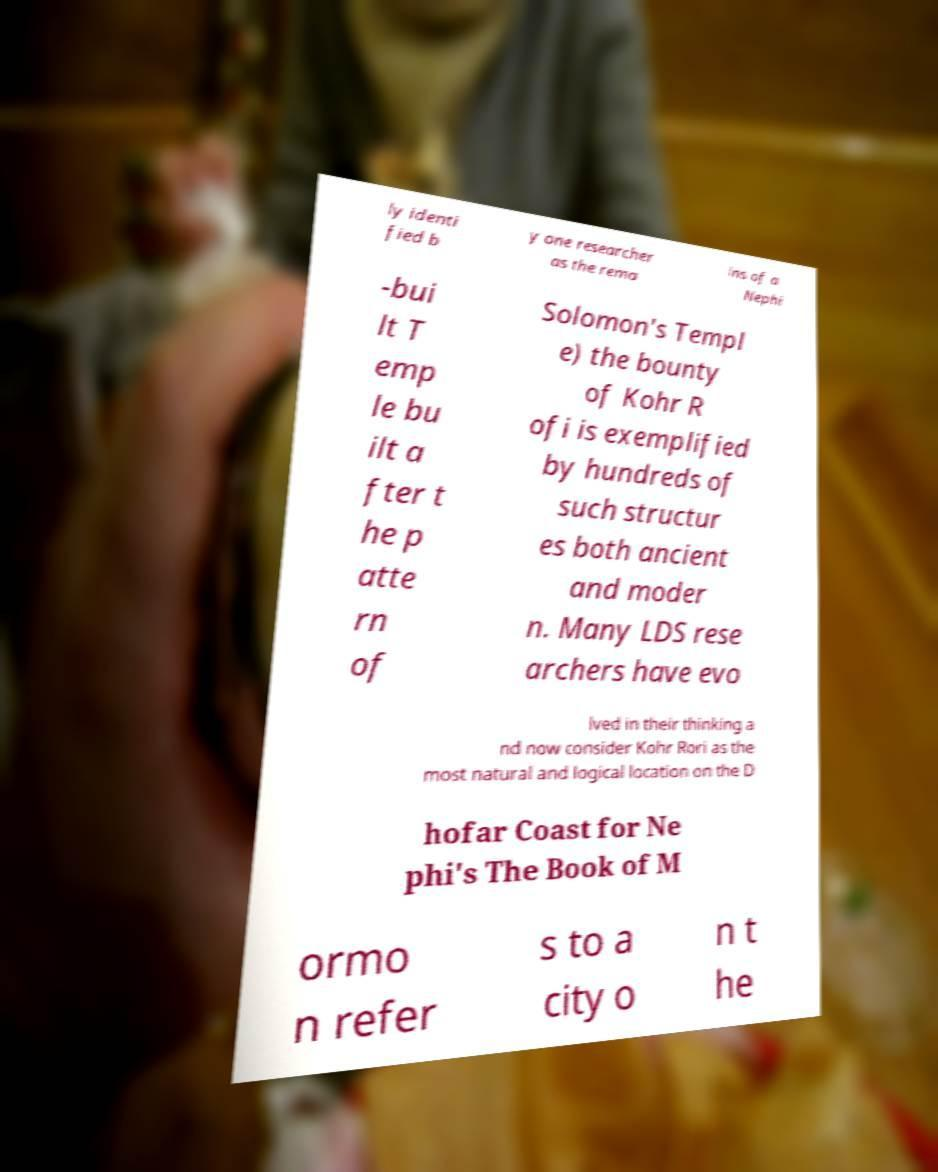Please identify and transcribe the text found in this image. ly identi fied b y one researcher as the rema ins of a Nephi -bui lt T emp le bu ilt a fter t he p atte rn of Solomon's Templ e) the bounty of Kohr R ofi is exemplified by hundreds of such structur es both ancient and moder n. Many LDS rese archers have evo lved in their thinking a nd now consider Kohr Rori as the most natural and logical location on the D hofar Coast for Ne phi's The Book of M ormo n refer s to a city o n t he 